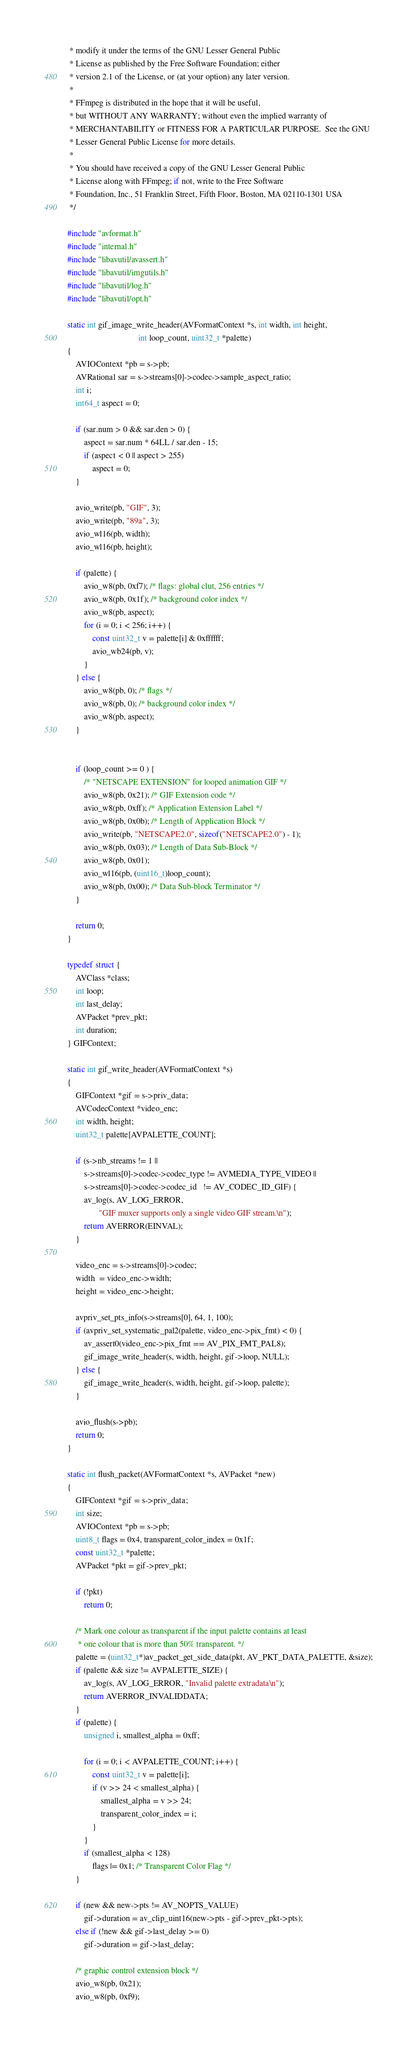Convert code to text. <code><loc_0><loc_0><loc_500><loc_500><_C_> * modify it under the terms of the GNU Lesser General Public
 * License as published by the Free Software Foundation; either
 * version 2.1 of the License, or (at your option) any later version.
 *
 * FFmpeg is distributed in the hope that it will be useful,
 * but WITHOUT ANY WARRANTY; without even the implied warranty of
 * MERCHANTABILITY or FITNESS FOR A PARTICULAR PURPOSE.  See the GNU
 * Lesser General Public License for more details.
 *
 * You should have received a copy of the GNU Lesser General Public
 * License along with FFmpeg; if not, write to the Free Software
 * Foundation, Inc., 51 Franklin Street, Fifth Floor, Boston, MA 02110-1301 USA
 */

#include "avformat.h"
#include "internal.h"
#include "libavutil/avassert.h"
#include "libavutil/imgutils.h"
#include "libavutil/log.h"
#include "libavutil/opt.h"

static int gif_image_write_header(AVFormatContext *s, int width, int height,
                                  int loop_count, uint32_t *palette)
{
    AVIOContext *pb = s->pb;
    AVRational sar = s->streams[0]->codec->sample_aspect_ratio;
    int i;
    int64_t aspect = 0;

    if (sar.num > 0 && sar.den > 0) {
        aspect = sar.num * 64LL / sar.den - 15;
        if (aspect < 0 || aspect > 255)
            aspect = 0;
    }

    avio_write(pb, "GIF", 3);
    avio_write(pb, "89a", 3);
    avio_wl16(pb, width);
    avio_wl16(pb, height);

    if (palette) {
        avio_w8(pb, 0xf7); /* flags: global clut, 256 entries */
        avio_w8(pb, 0x1f); /* background color index */
        avio_w8(pb, aspect);
        for (i = 0; i < 256; i++) {
            const uint32_t v = palette[i] & 0xffffff;
            avio_wb24(pb, v);
        }
    } else {
        avio_w8(pb, 0); /* flags */
        avio_w8(pb, 0); /* background color index */
        avio_w8(pb, aspect);
    }


    if (loop_count >= 0 ) {
        /* "NETSCAPE EXTENSION" for looped animation GIF */
        avio_w8(pb, 0x21); /* GIF Extension code */
        avio_w8(pb, 0xff); /* Application Extension Label */
        avio_w8(pb, 0x0b); /* Length of Application Block */
        avio_write(pb, "NETSCAPE2.0", sizeof("NETSCAPE2.0") - 1);
        avio_w8(pb, 0x03); /* Length of Data Sub-Block */
        avio_w8(pb, 0x01);
        avio_wl16(pb, (uint16_t)loop_count);
        avio_w8(pb, 0x00); /* Data Sub-block Terminator */
    }

    return 0;
}

typedef struct {
    AVClass *class;
    int loop;
    int last_delay;
    AVPacket *prev_pkt;
    int duration;
} GIFContext;

static int gif_write_header(AVFormatContext *s)
{
    GIFContext *gif = s->priv_data;
    AVCodecContext *video_enc;
    int width, height;
    uint32_t palette[AVPALETTE_COUNT];

    if (s->nb_streams != 1 ||
        s->streams[0]->codec->codec_type != AVMEDIA_TYPE_VIDEO ||
        s->streams[0]->codec->codec_id   != AV_CODEC_ID_GIF) {
        av_log(s, AV_LOG_ERROR,
               "GIF muxer supports only a single video GIF stream.\n");
        return AVERROR(EINVAL);
    }

    video_enc = s->streams[0]->codec;
    width  = video_enc->width;
    height = video_enc->height;

    avpriv_set_pts_info(s->streams[0], 64, 1, 100);
    if (avpriv_set_systematic_pal2(palette, video_enc->pix_fmt) < 0) {
        av_assert0(video_enc->pix_fmt == AV_PIX_FMT_PAL8);
        gif_image_write_header(s, width, height, gif->loop, NULL);
    } else {
        gif_image_write_header(s, width, height, gif->loop, palette);
    }

    avio_flush(s->pb);
    return 0;
}

static int flush_packet(AVFormatContext *s, AVPacket *new)
{
    GIFContext *gif = s->priv_data;
    int size;
    AVIOContext *pb = s->pb;
    uint8_t flags = 0x4, transparent_color_index = 0x1f;
    const uint32_t *palette;
    AVPacket *pkt = gif->prev_pkt;

    if (!pkt)
        return 0;

    /* Mark one colour as transparent if the input palette contains at least
     * one colour that is more than 50% transparent. */
    palette = (uint32_t*)av_packet_get_side_data(pkt, AV_PKT_DATA_PALETTE, &size);
    if (palette && size != AVPALETTE_SIZE) {
        av_log(s, AV_LOG_ERROR, "Invalid palette extradata\n");
        return AVERROR_INVALIDDATA;
    }
    if (palette) {
        unsigned i, smallest_alpha = 0xff;

        for (i = 0; i < AVPALETTE_COUNT; i++) {
            const uint32_t v = palette[i];
            if (v >> 24 < smallest_alpha) {
                smallest_alpha = v >> 24;
                transparent_color_index = i;
            }
        }
        if (smallest_alpha < 128)
            flags |= 0x1; /* Transparent Color Flag */
    }

    if (new && new->pts != AV_NOPTS_VALUE)
        gif->duration = av_clip_uint16(new->pts - gif->prev_pkt->pts);
    else if (!new && gif->last_delay >= 0)
        gif->duration = gif->last_delay;

    /* graphic control extension block */
    avio_w8(pb, 0x21);
    avio_w8(pb, 0xf9);</code> 